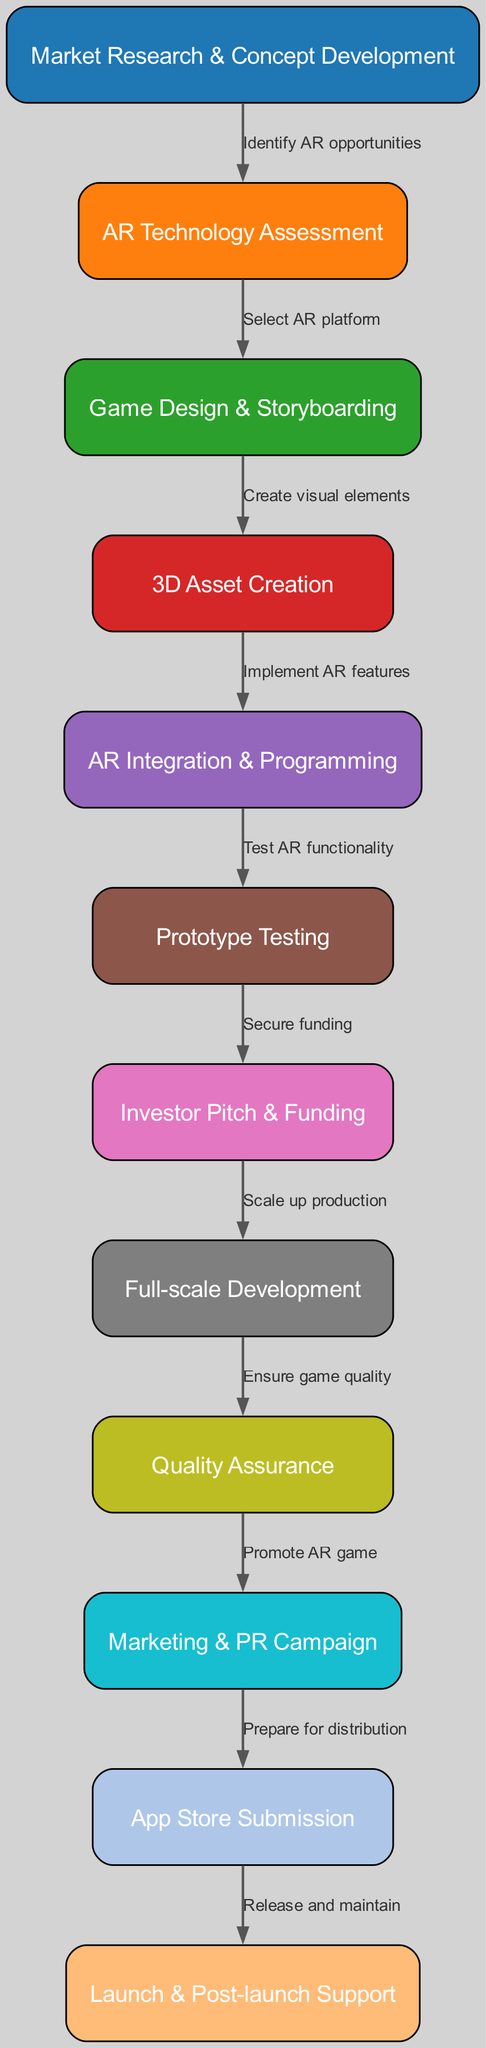What is the first step in the AR game development pipeline? The first step in the pipeline is "Market Research & Concept Development," which identifies potential AR opportunities.
Answer: Market Research & Concept Development How many total nodes are there in the diagram? The diagram contains a total of 12 nodes, representing different steps in the AR game development pipeline.
Answer: 12 What step follows "Prototype Testing"? Following "Prototype Testing," the next step is "Investor Pitch & Funding," which helps secure the necessary financial backing.
Answer: Investor Pitch & Funding What is the relationship between "Game Design & Storyboarding" and "AR Technology Assessment"? The relationship is that "AR Technology Assessment" is a prerequisite that leads into "Game Design & Storyboarding." This means you assess the technology before creating game design elements.
Answer: Select AR platform Which step is responsible for ensuring the quality of the game? The step responsible for ensuring game quality is "Quality Assurance," which systematically tests the game before launch to identify issues.
Answer: Quality Assurance What follows directly after "Full-scale Development"? The step that follows "Full-scale Development" is "Quality Assurance," ensuring the final game meets quality standards before promotion and marketing.
Answer: Quality Assurance How many edges are there connecting the nodes in the diagram? The diagram consists of 11 edges, each representing a connection between consecutive steps in the development pipeline.
Answer: 11 What is the final step in the AR game development pipeline? The final step in the pipeline is "Launch & Post-launch Support," which involves releasing the game and providing ongoing support to users.
Answer: Launch & Post-launch Support What is the main purpose of "Marketing & PR Campaign"? The main purpose of "Marketing & PR Campaign" is to promote the AR game to the target audience and increase visibility prior to its launch.
Answer: Promote AR game 